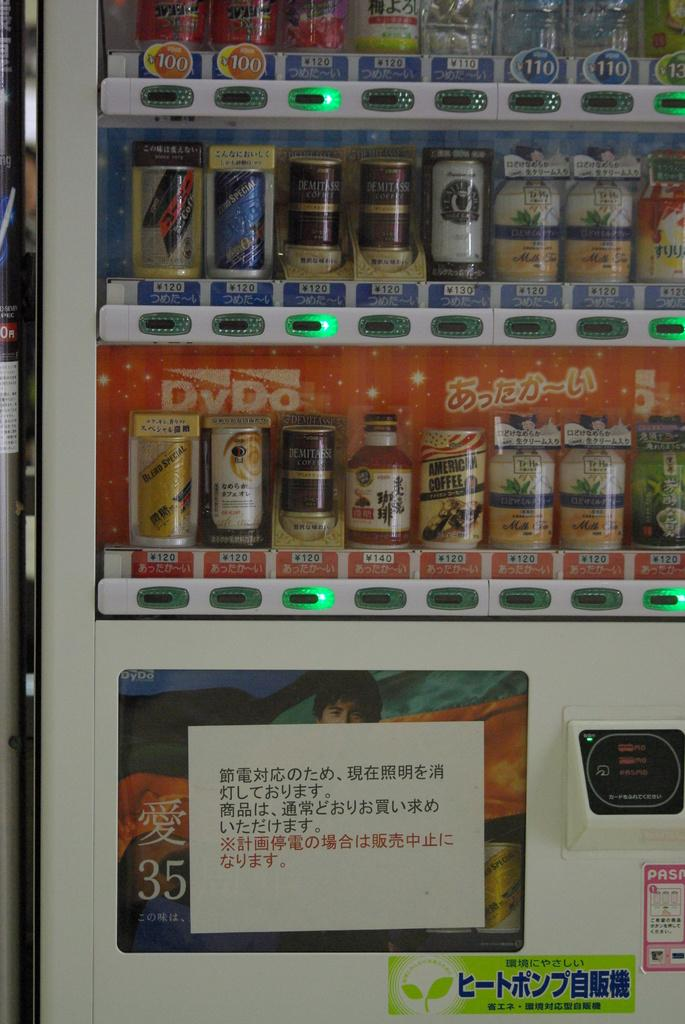<image>
Create a compact narrative representing the image presented. A vending machine sells a wide variety of items including American coffee. 